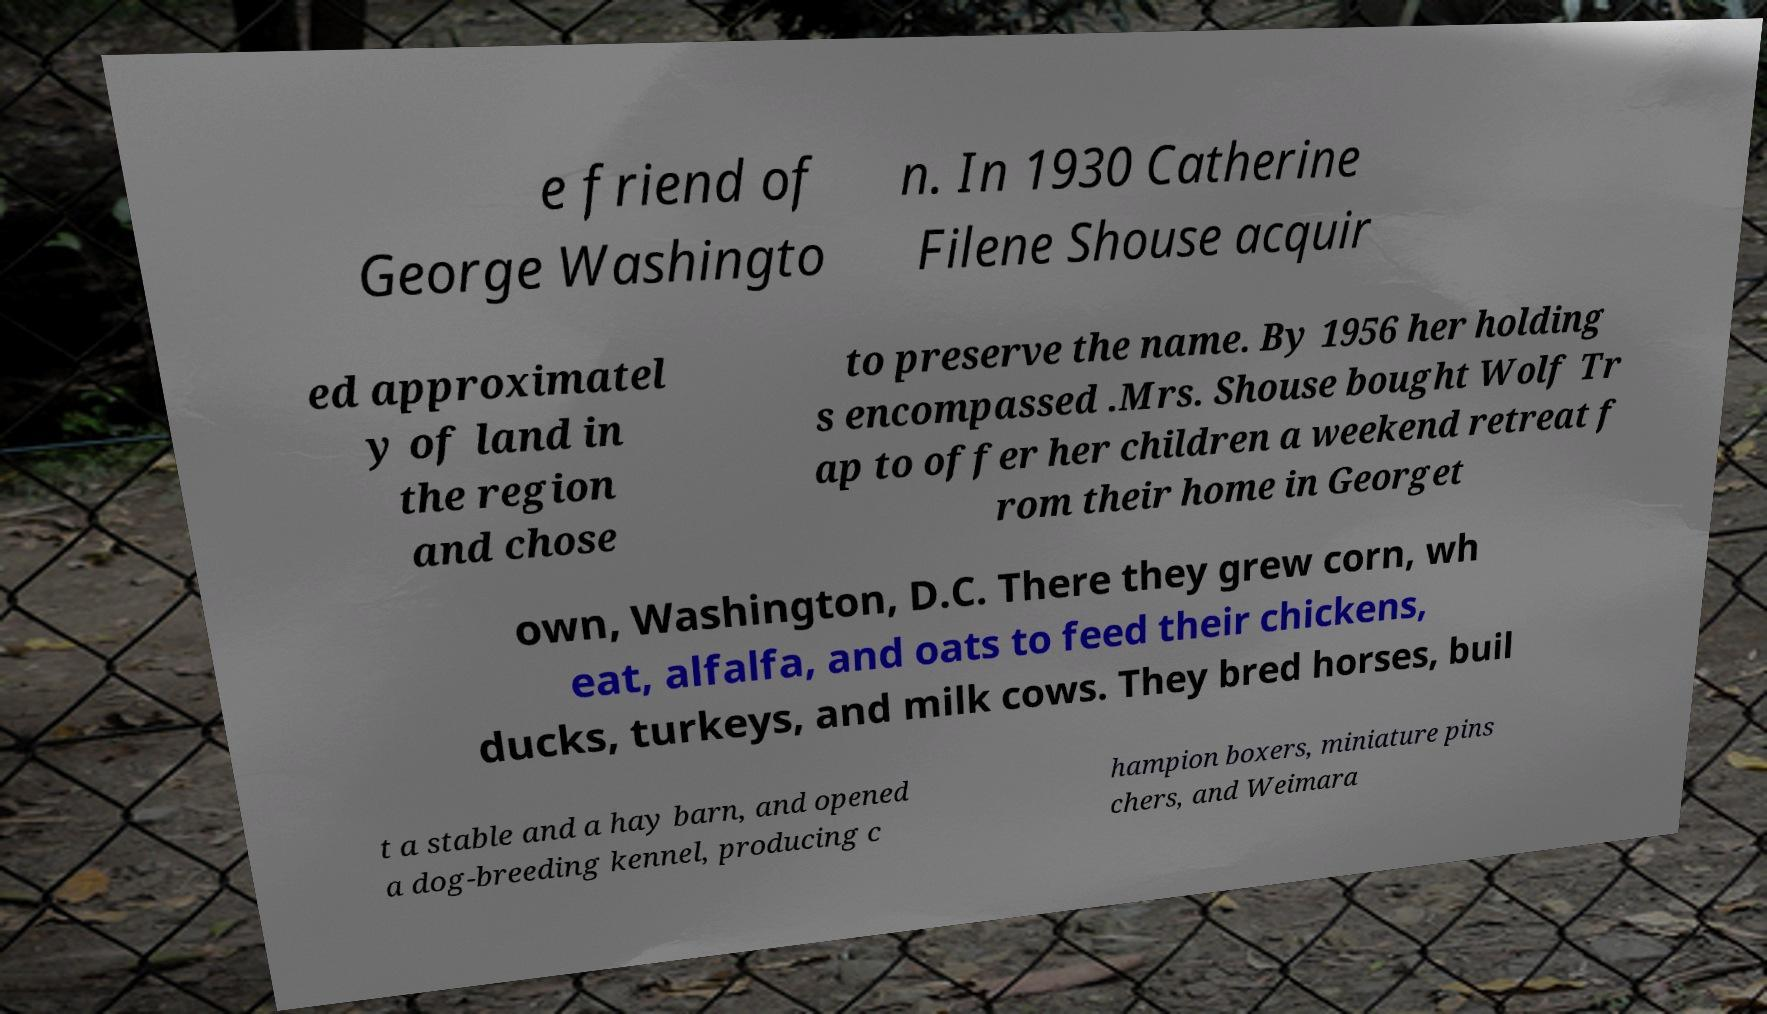Can you accurately transcribe the text from the provided image for me? e friend of George Washingto n. In 1930 Catherine Filene Shouse acquir ed approximatel y of land in the region and chose to preserve the name. By 1956 her holding s encompassed .Mrs. Shouse bought Wolf Tr ap to offer her children a weekend retreat f rom their home in Georget own, Washington, D.C. There they grew corn, wh eat, alfalfa, and oats to feed their chickens, ducks, turkeys, and milk cows. They bred horses, buil t a stable and a hay barn, and opened a dog-breeding kennel, producing c hampion boxers, miniature pins chers, and Weimara 